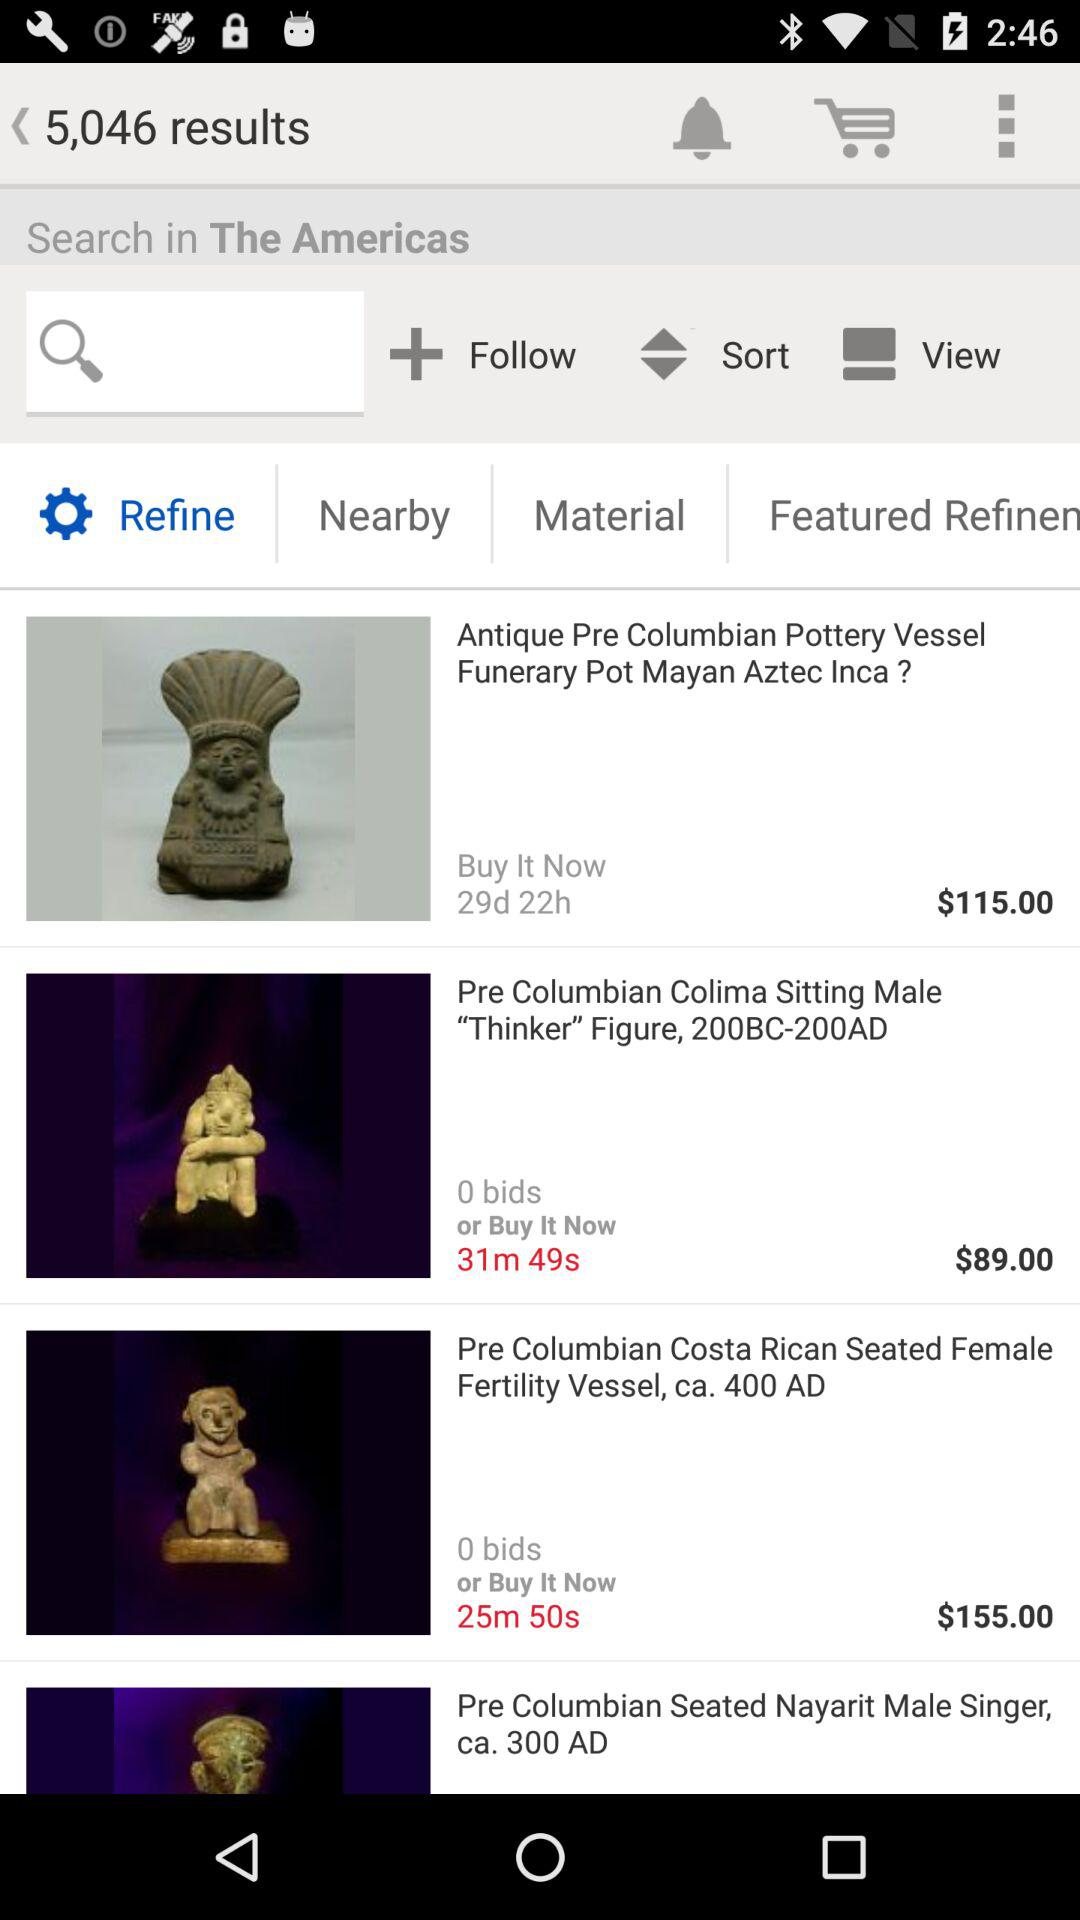What is the price of the "Pre Columbian Costa Rican Seated Female Fertility Vessel"? The price of the "Pre Columbian Costa Rican Seated Female Fertility Vessel" is $155.00. 